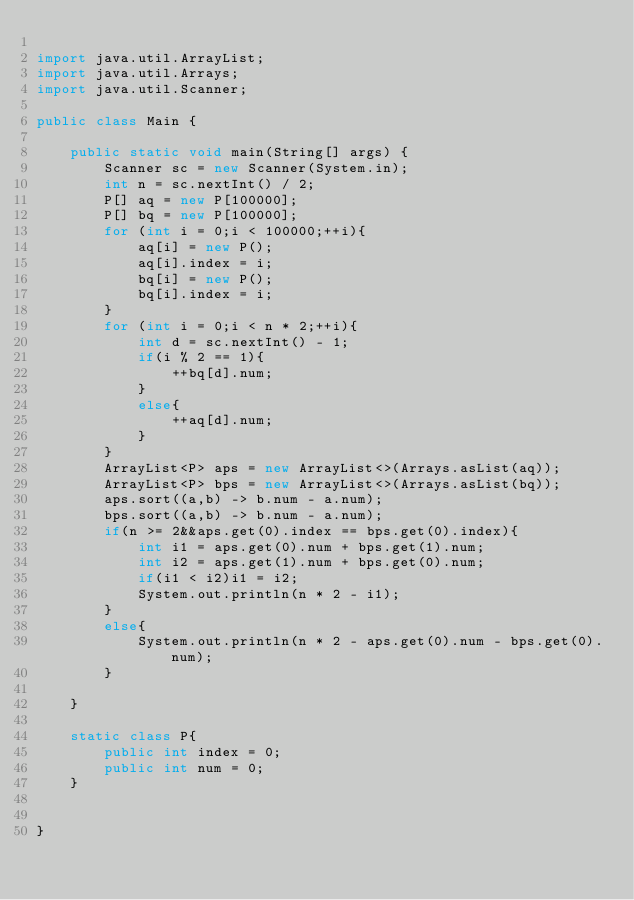<code> <loc_0><loc_0><loc_500><loc_500><_Java_>
import java.util.ArrayList;
import java.util.Arrays;
import java.util.Scanner;

public class Main {

    public static void main(String[] args) {
        Scanner sc = new Scanner(System.in);
        int n = sc.nextInt() / 2;
        P[] aq = new P[100000];
        P[] bq = new P[100000];
        for (int i = 0;i < 100000;++i){
            aq[i] = new P();
            aq[i].index = i;
            bq[i] = new P();
            bq[i].index = i;
        }
        for (int i = 0;i < n * 2;++i){
            int d = sc.nextInt() - 1;
            if(i % 2 == 1){
                ++bq[d].num;
            }
            else{
                ++aq[d].num;
            }
        }
        ArrayList<P> aps = new ArrayList<>(Arrays.asList(aq));
        ArrayList<P> bps = new ArrayList<>(Arrays.asList(bq));
        aps.sort((a,b) -> b.num - a.num);
        bps.sort((a,b) -> b.num - a.num);
        if(n >= 2&&aps.get(0).index == bps.get(0).index){
            int i1 = aps.get(0).num + bps.get(1).num;
            int i2 = aps.get(1).num + bps.get(0).num;
            if(i1 < i2)i1 = i2;
            System.out.println(n * 2 - i1);
        }
        else{
            System.out.println(n * 2 - aps.get(0).num - bps.get(0).num);
        }

    }

    static class P{
        public int index = 0;
        public int num = 0;
    }


}



</code> 